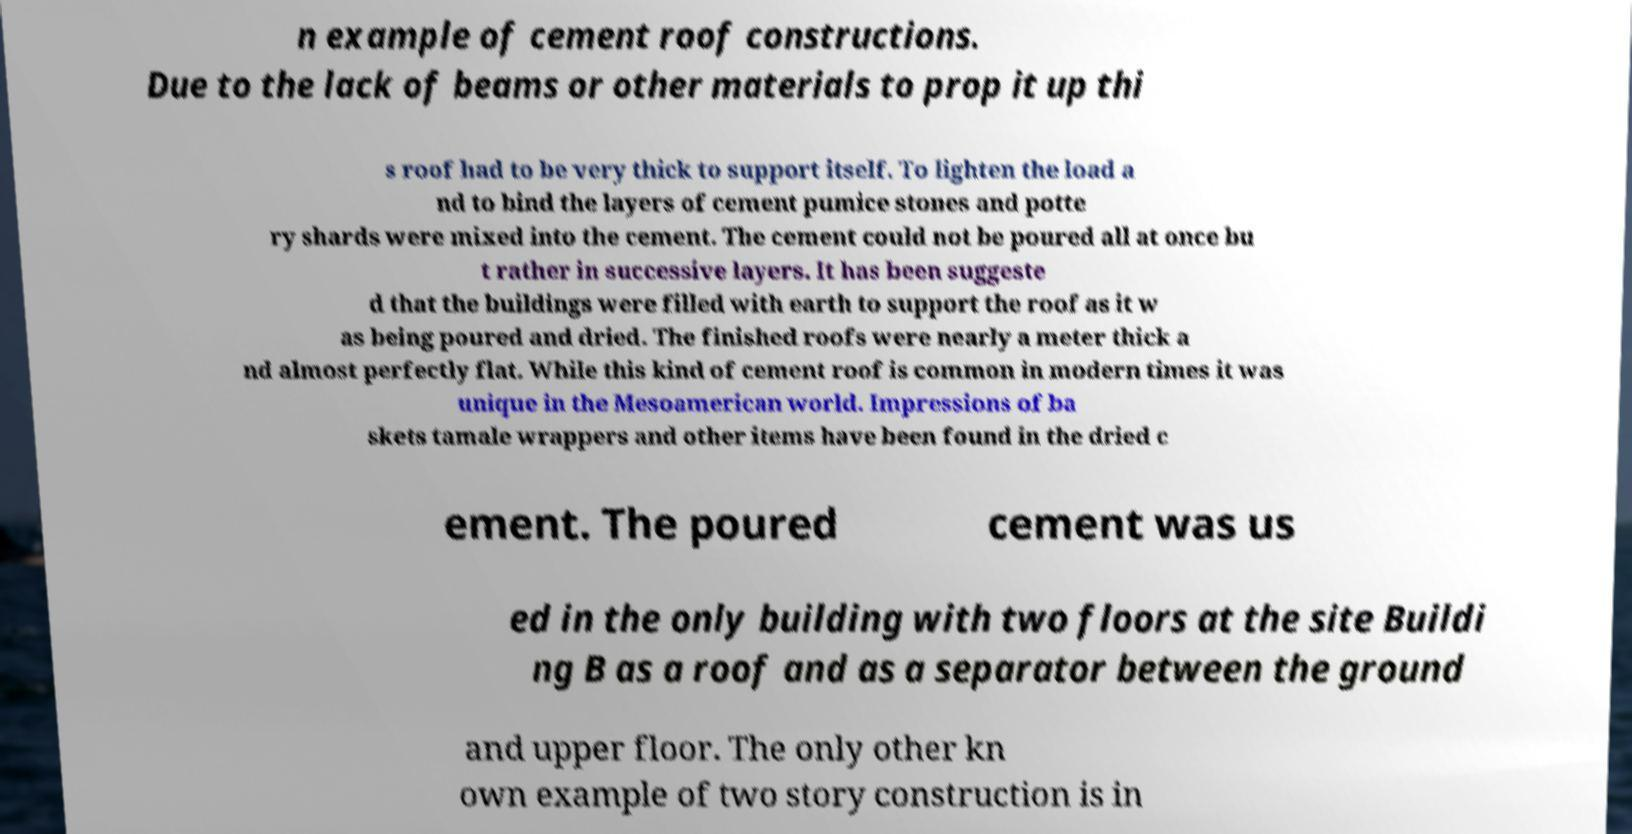Could you assist in decoding the text presented in this image and type it out clearly? n example of cement roof constructions. Due to the lack of beams or other materials to prop it up thi s roof had to be very thick to support itself. To lighten the load a nd to bind the layers of cement pumice stones and potte ry shards were mixed into the cement. The cement could not be poured all at once bu t rather in successive layers. It has been suggeste d that the buildings were filled with earth to support the roof as it w as being poured and dried. The finished roofs were nearly a meter thick a nd almost perfectly flat. While this kind of cement roof is common in modern times it was unique in the Mesoamerican world. Impressions of ba skets tamale wrappers and other items have been found in the dried c ement. The poured cement was us ed in the only building with two floors at the site Buildi ng B as a roof and as a separator between the ground and upper floor. The only other kn own example of two story construction is in 